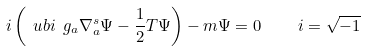<formula> <loc_0><loc_0><loc_500><loc_500>i \left ( \ u b i \ g _ { a } \nabla _ { a } ^ { s } \Psi - { \frac { 1 } { 2 } } T \Psi \right ) - m \Psi = 0 \quad i = \sqrt { - 1 }</formula> 